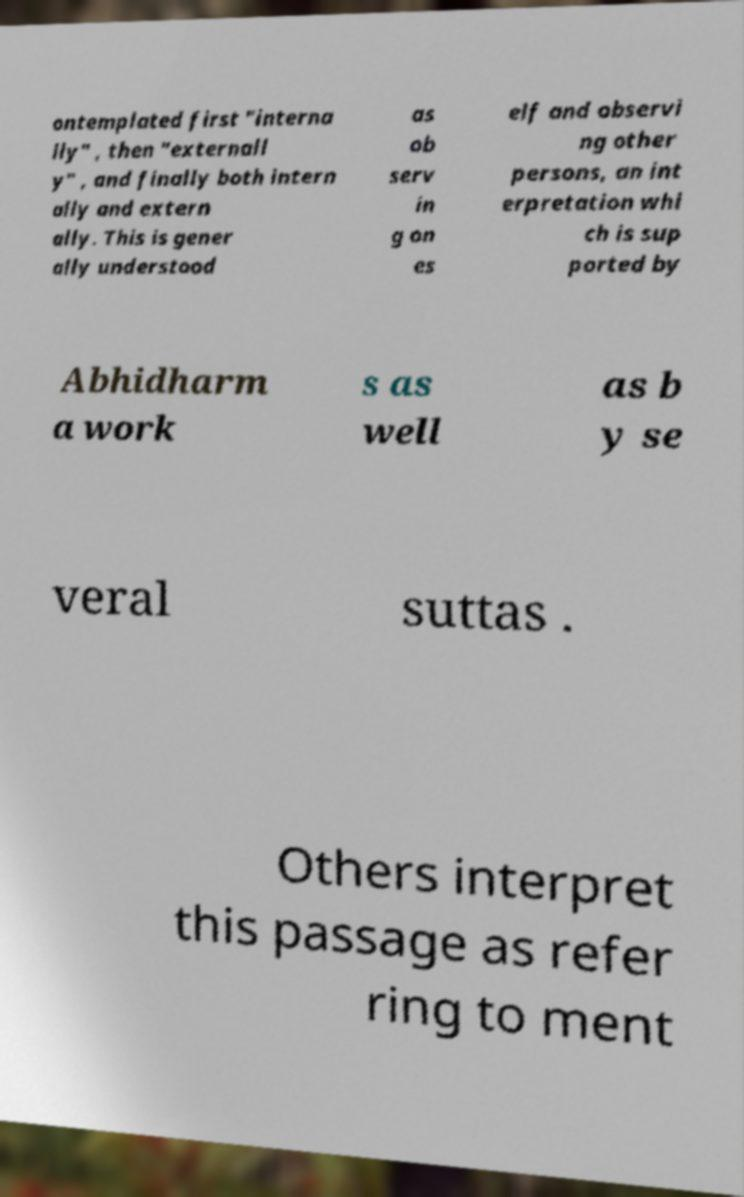Could you extract and type out the text from this image? ontemplated first "interna lly" , then "externall y" , and finally both intern ally and extern ally. This is gener ally understood as ob serv in g on es elf and observi ng other persons, an int erpretation whi ch is sup ported by Abhidharm a work s as well as b y se veral suttas . Others interpret this passage as refer ring to ment 